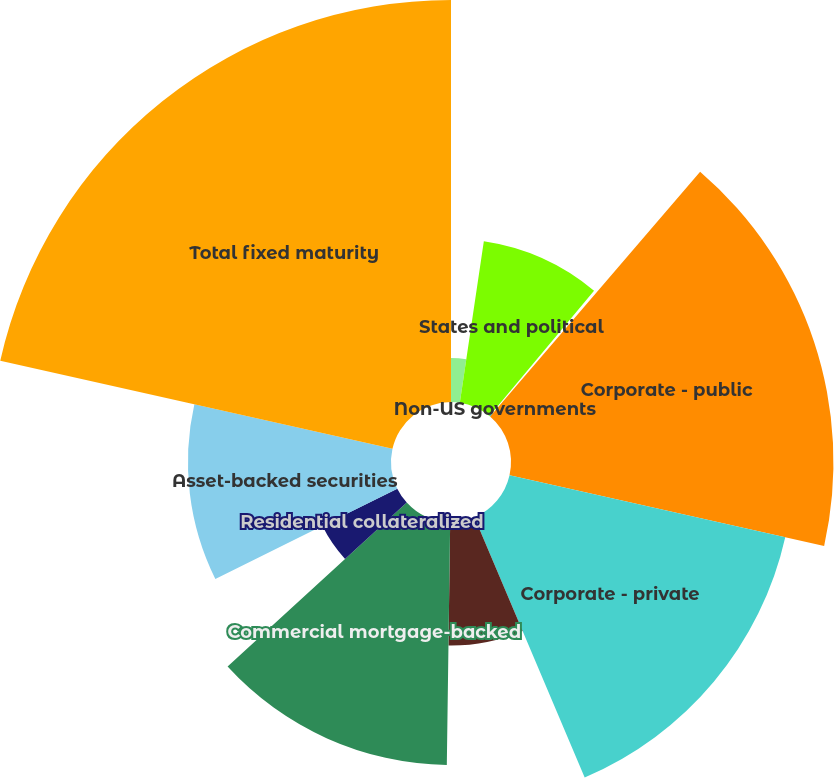<chart> <loc_0><loc_0><loc_500><loc_500><pie_chart><fcel>US Government and agencies<fcel>States and political<fcel>Non-US governments<fcel>Corporate - public<fcel>Corporate - private<fcel>Residential pass-through<fcel>Commercial mortgage-backed<fcel>Residential collateralized<fcel>Asset-backed securities<fcel>Total fixed maturity<nl><fcel>2.35%<fcel>8.72%<fcel>0.22%<fcel>17.23%<fcel>15.1%<fcel>6.6%<fcel>12.98%<fcel>4.47%<fcel>10.85%<fcel>21.48%<nl></chart> 